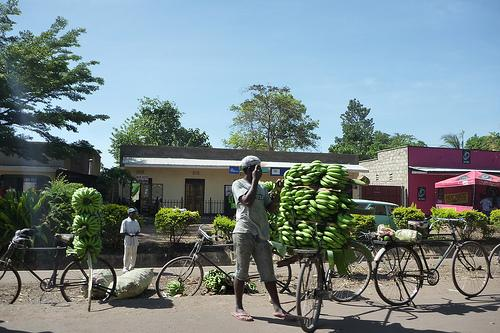Describe the man wearing a hat and his location. The man wearing a hat is standing in front of the building. Which item is placed on the bicycle and what is its color? A tall stack of melons is placed on the bicycle and they are green in color. What color are the bananas on the bike? The bananas on the bike are green. What is coming out of the red building? Smoke is rising into the air from the red building. Identify the color of the wall on the front of the building and the type of fence in front of the house. The wall on the front of the building is painted pink, and there is a wrought iron fence in front of the house. Describe where the people are and what they are all doing. The people are in a city, on the street, using bicycles, enjoying the sunshine and doing local business. What is the condition of the bananas and what are the people doing with them? The bananas are green and some people are selling and transporting them on bicycles. Explain what the man with the white hat is doing. The man with the white hat is standing beside a bicycle. What is the subject casting the shadow on the ground? A person standing next to a bike is casting the shadow on the ground. List the items people are enjoying during the daytime in this image. People are enjoying sunshine, using bicycles, doing local business, and selling and transporting green bananas. 